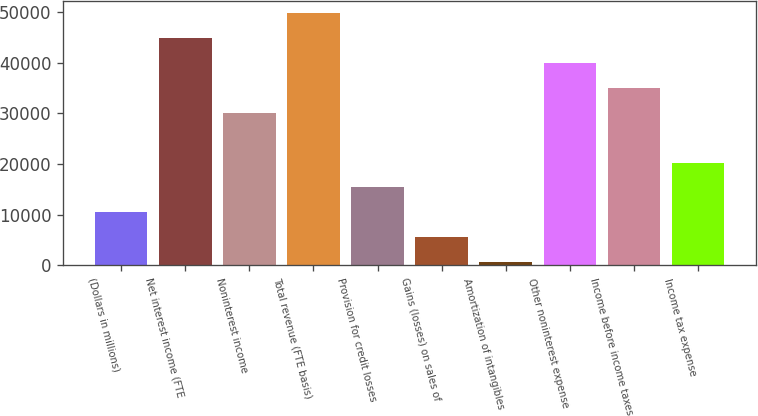<chart> <loc_0><loc_0><loc_500><loc_500><bar_chart><fcel>(Dollars in millions)<fcel>Net interest income (FTE<fcel>Noninterest income<fcel>Total revenue (FTE basis)<fcel>Provision for credit losses<fcel>Gains (losses) on sales of<fcel>Amortization of intangibles<fcel>Other noninterest expense<fcel>Income before income taxes<fcel>Income tax expense<nl><fcel>10467.6<fcel>44780.2<fcel>30074.8<fcel>49682<fcel>15369.4<fcel>5565.8<fcel>664<fcel>39878.4<fcel>34976.6<fcel>20271.2<nl></chart> 